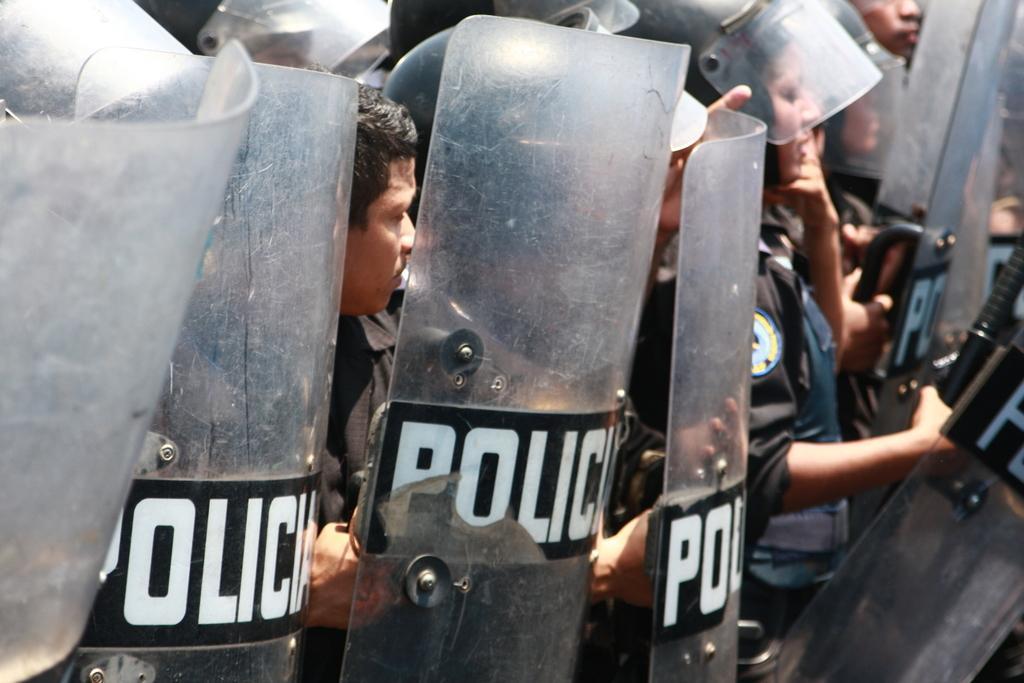Please provide a concise description of this image. There are group of police taking charge against someone,they are wearing black uniform. 